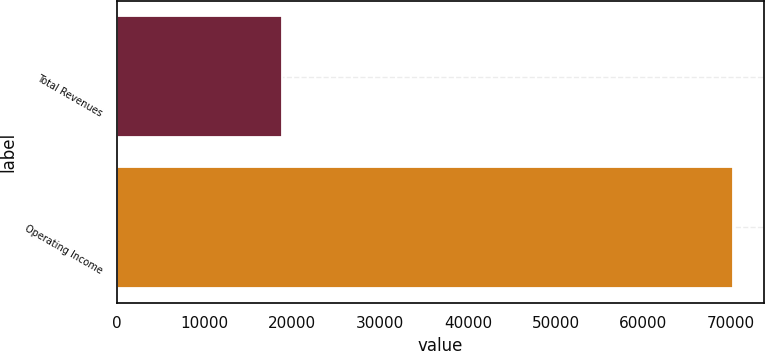<chart> <loc_0><loc_0><loc_500><loc_500><bar_chart><fcel>Total Revenues<fcel>Operating Income<nl><fcel>18762<fcel>70224<nl></chart> 